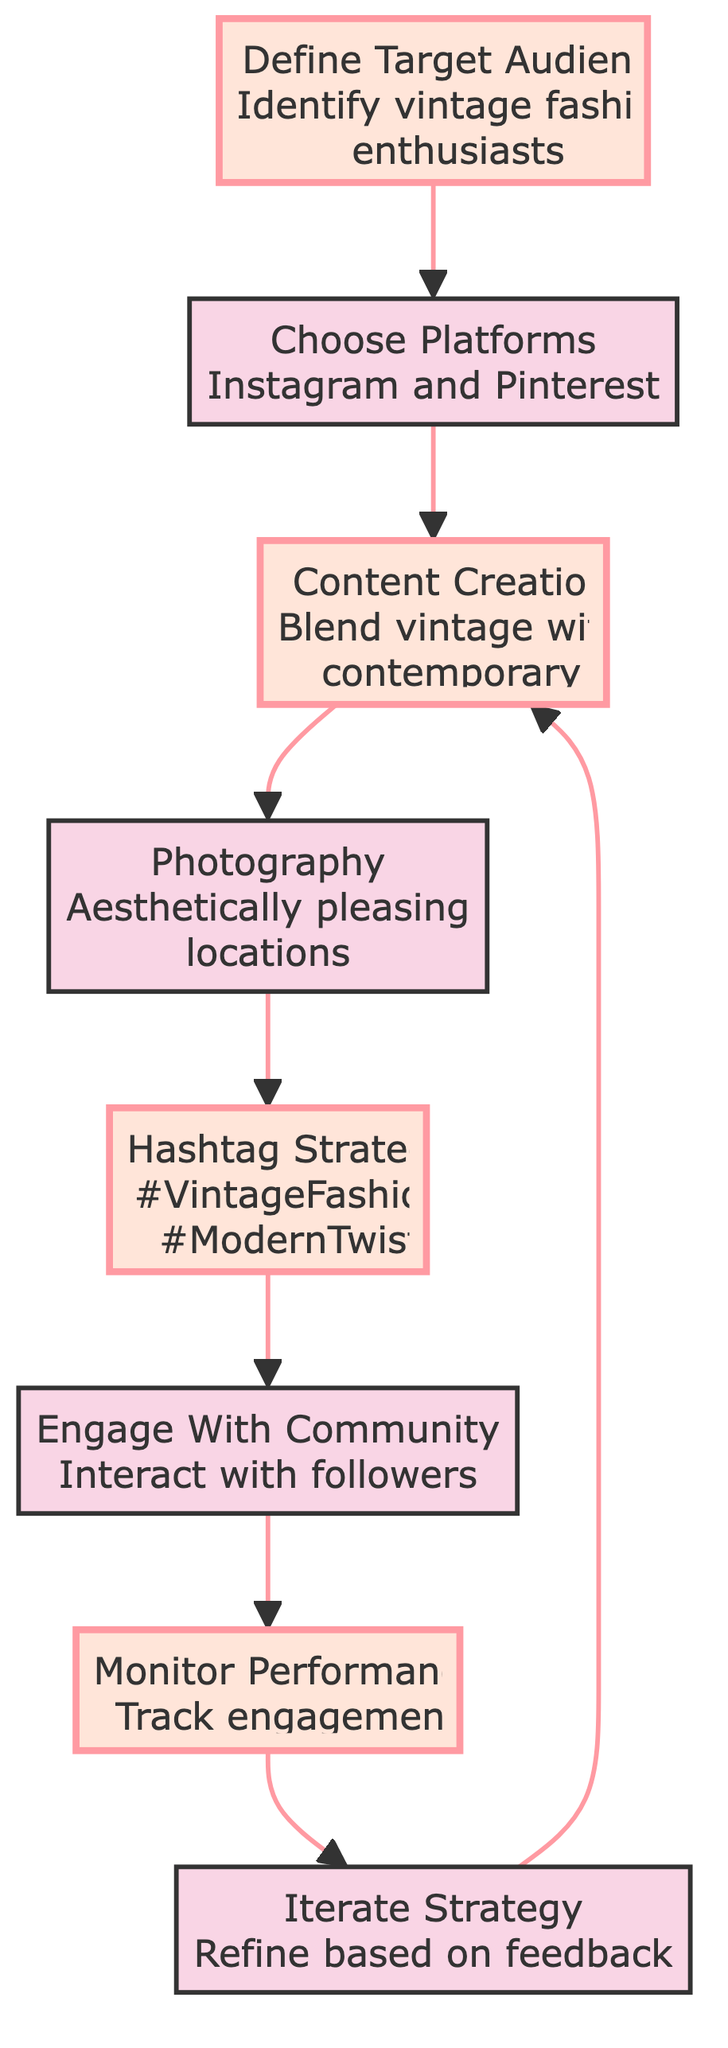What is the first step in the flow chart? The first step listed in the flow chart is "Define Target Audience."
Answer: Define Target Audience How many total steps are in the flow chart? Counting each distinct node in the flow chart, there are a total of eight steps listed.
Answer: 8 Which platform is specifically mentioned for selecting in the second step? The second step indicates that Instagram is one of the selected platforms.
Answer: Instagram What type of locations should be used for photography according to the chart? The chart specifies that aesthetically pleasing locations should be used for photography.
Answer: Aesthetically pleasing locations What is the last step in the flow chart? The last step noted in the flow chart is "Iterate Strategy."
Answer: Iterate Strategy What is the relationship between "Content Creation" and "Photography"? "Content Creation" leads directly to "Photography," indicating that photography follows after content creation.
Answer: Leads to How many hashtags are suggested in the Hashtag Strategy step? The Hashtag Strategy mentions two specific hashtags: "#VintageFashion" and "#ModernTwist."
Answer: 2 What action is recommended after monitoring performance? After monitoring performance, the recommended action is to "Iterate Strategy."
Answer: Iterate Strategy Which two elements are highlighted in the diagram? The highlighted elements in the diagram are "Define Target Audience" and "Content Creation."
Answer: Define Target Audience, Content Creation 